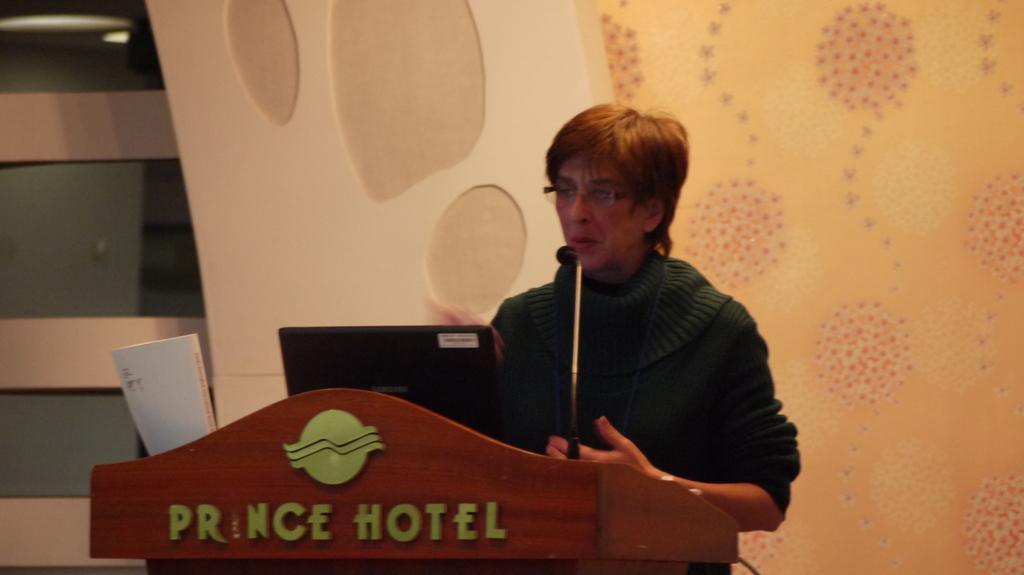How would you summarize this image in a sentence or two? In this picture we can see a woman is speaking something, there is a podium in front of her, we can see a book, a laptop and a microphone on the podium, in the background there is a wall. 